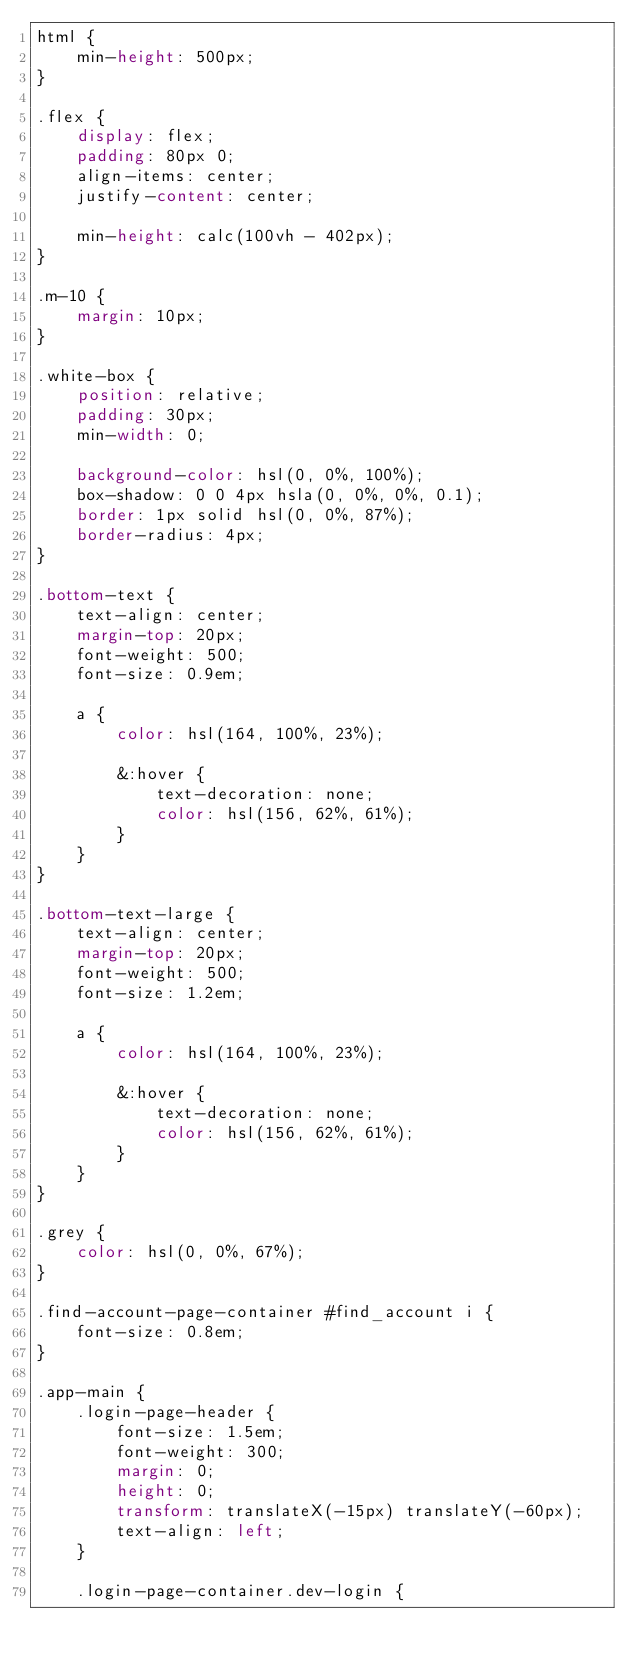<code> <loc_0><loc_0><loc_500><loc_500><_CSS_>html {
    min-height: 500px;
}

.flex {
    display: flex;
    padding: 80px 0;
    align-items: center;
    justify-content: center;

    min-height: calc(100vh - 402px);
}

.m-10 {
    margin: 10px;
}

.white-box {
    position: relative;
    padding: 30px;
    min-width: 0;

    background-color: hsl(0, 0%, 100%);
    box-shadow: 0 0 4px hsla(0, 0%, 0%, 0.1);
    border: 1px solid hsl(0, 0%, 87%);
    border-radius: 4px;
}

.bottom-text {
    text-align: center;
    margin-top: 20px;
    font-weight: 500;
    font-size: 0.9em;

    a {
        color: hsl(164, 100%, 23%);

        &:hover {
            text-decoration: none;
            color: hsl(156, 62%, 61%);
        }
    }
}

.bottom-text-large {
    text-align: center;
    margin-top: 20px;
    font-weight: 500;
    font-size: 1.2em;

    a {
        color: hsl(164, 100%, 23%);

        &:hover {
            text-decoration: none;
            color: hsl(156, 62%, 61%);
        }
    }
}

.grey {
    color: hsl(0, 0%, 67%);
}

.find-account-page-container #find_account i {
    font-size: 0.8em;
}

.app-main {
    .login-page-header {
        font-size: 1.5em;
        font-weight: 300;
        margin: 0;
        height: 0;
        transform: translateX(-15px) translateY(-60px);
        text-align: left;
    }

    .login-page-container.dev-login {</code> 